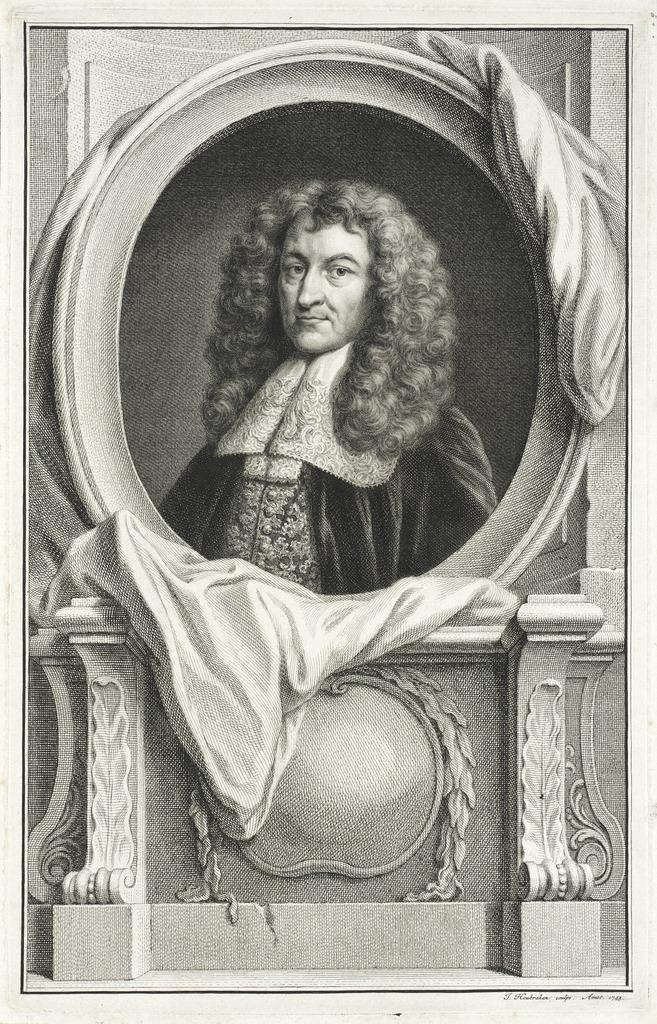What is the main object in the image? There is a cloth on a frame in the image. Where is the cloth located in relation to other objects? The cloth is near a wall. What is the color scheme of the image? The image is in black and white. What is the price of the cow in the image? There is no cow present in the image. What process is being depicted in the image? The image does not depict a process; it shows a cloth on a frame near a wall. 